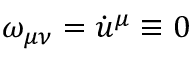Convert formula to latex. <formula><loc_0><loc_0><loc_500><loc_500>\omega _ { \mu \nu } = \dot { u } ^ { \mu } \equiv 0</formula> 